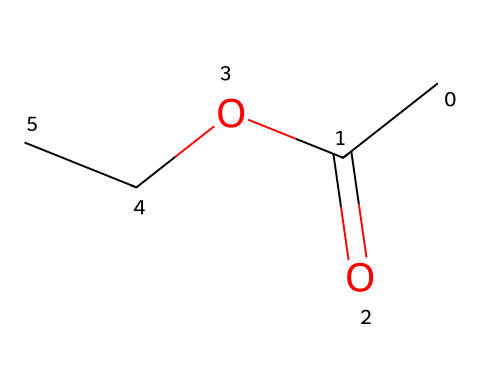What is the molecular formula of ethyl acetate? The molecular formula can be derived from the depicted chemical structure by counting the types and numbers of each atom: 2 carbon (C) from the ethyl group, 3 hydrogen (H) from the ethyl group, 1 carbon (C) from the carbonyl group, 2 oxygen (O), which leads to the formula C4H8O2.
Answer: C4H8O2 How many carbon atoms are present in ethyl acetate? By observing the SMILES representation, the carbon atoms include two in the ethyl group and one in the carbonyl group, totaling three carbon atoms.
Answer: 4 What type of functional group is present in ethyl acetate? The chemical structure includes a carbonyl group (C=O) bonded to an oxygen (O), indicating that the functional group present in ethyl acetate is an ester.
Answer: ester What is the total number of hydrogen atoms in ethyl acetate? By considering the molecular formula derived previously (C4H8O2), the total number of hydrogen atoms is 8 as indicated in the formula.
Answer: 8 What is the primary use of ethyl acetate? Ethyl acetate is commonly known for its applications as a solvent, particularly in electronic component cleaning and various other industrial processes.
Answer: solvent Does ethyl acetate exhibit polarity, and if so, why? Ethyl acetate exhibits some polarity due to the presence of the carbonyl group (C=O), which has significant electronegativity differences between carbon and oxygen, contributing to dipole moments.
Answer: yes 